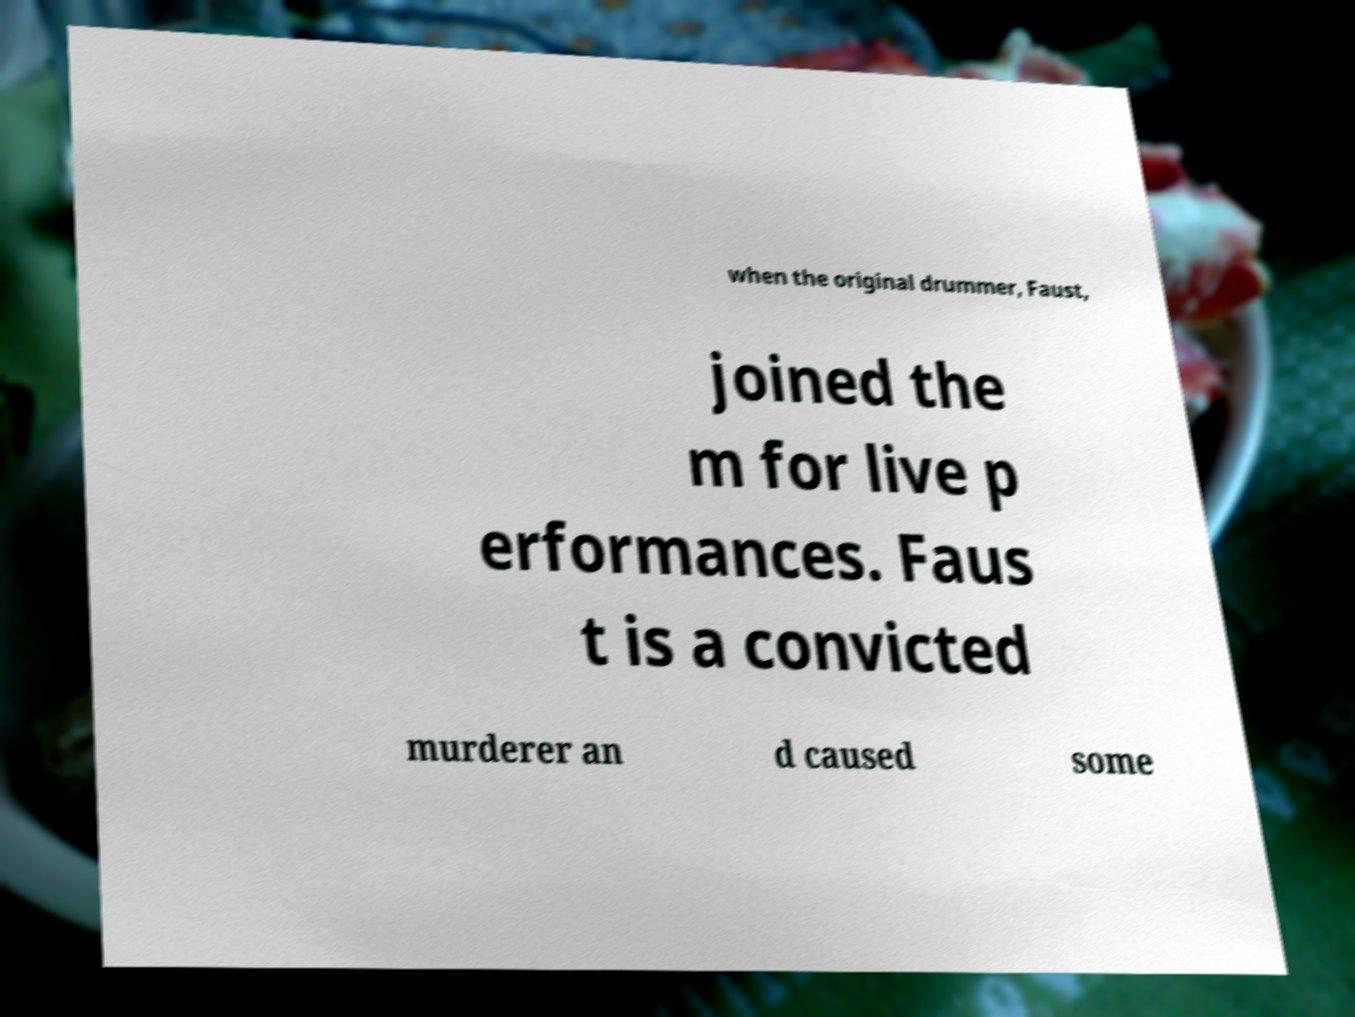Can you read and provide the text displayed in the image?This photo seems to have some interesting text. Can you extract and type it out for me? when the original drummer, Faust, joined the m for live p erformances. Faus t is a convicted murderer an d caused some 